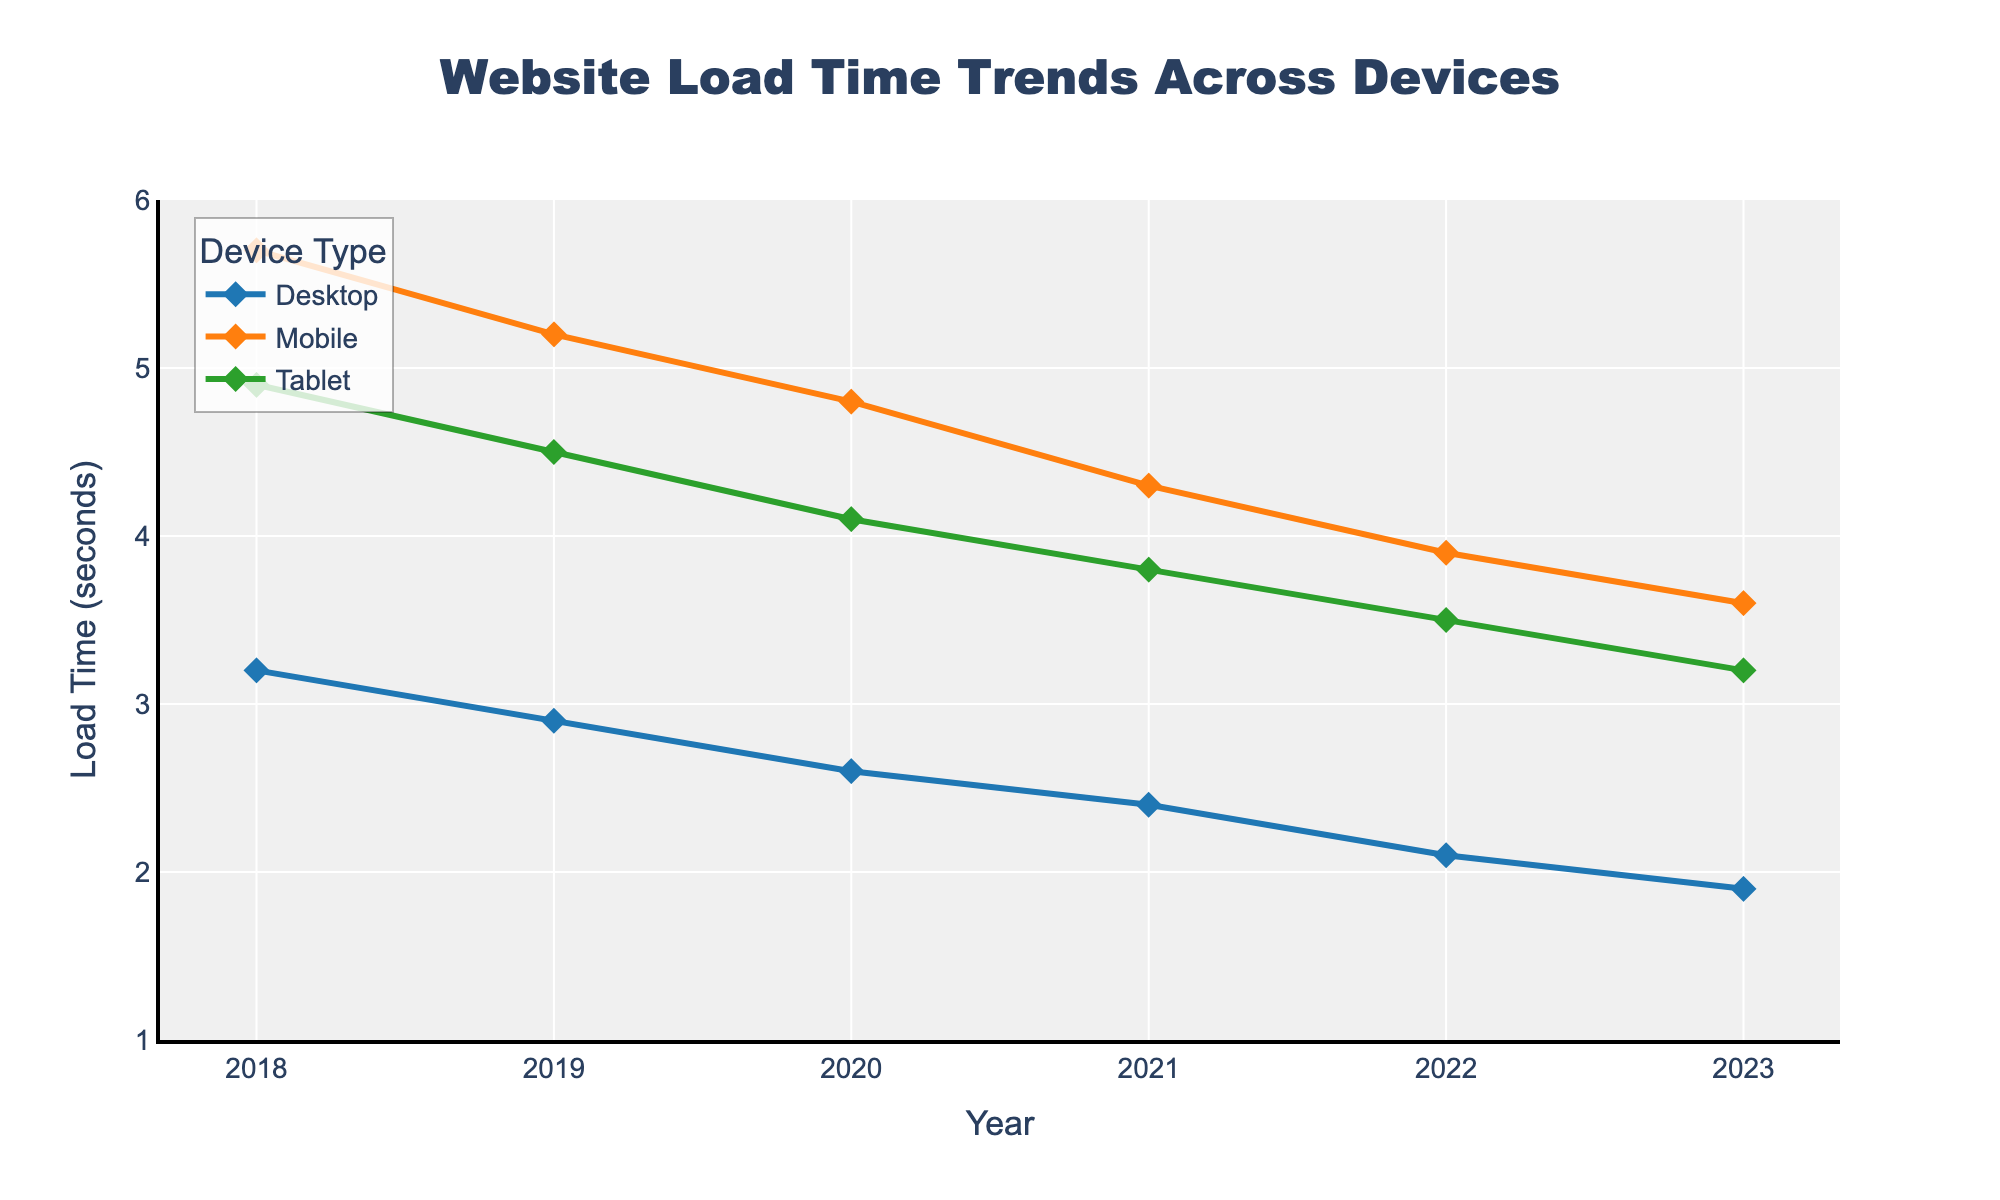What is the trend of website load times for Mobile devices from 2018 to 2023? Examine the line corresponding to Mobile devices. The load times have gradually decreased each year: from 5.7 seconds in 2018 to 3.6 seconds in 2023
Answer: Decreasing In which year did Desktop and Tablet devices have the same load time, if any? Track the lines for both Desktop and Tablet devices across all years. In each year, Desktop load times are consistently lower than Tablet load times, so they never match.
Answer: Never What is the difference in website load time between Mobile and Desktop devices in 2022? In 2022, the load time for Mobile is 3.9 seconds, and for Desktop, it is 2.1 seconds. Subtract the Desktop value from the Mobile value: 3.9 - 2.1
Answer: 1.8 seconds Which device showed the most significant improvement in load time from 2018 to 2023? Calculate the total reduction in load time for each device over the period. Desktop: 3.2 - 1.9 = 1.3 seconds, Mobile: 5.7 - 3.6 = 2.1 seconds, Tablet: 4.9 - 3.2 = 1.7 seconds. The Mobile device has the largest reduction (2.1 seconds).
Answer: Mobile What was the average load time for Tablet devices over the 6-year period? Sum the Tablet load times and divide by the number of years: (4.9 + 4.5 + 4.1 + 3.8 + 3.5 + 3.2) / 6. This equals 24 / 6
Answer: 4.0 seconds Compare the load times for Desktop and Mobile devices in the year 2023. Which one is faster, and by how much? For 2023, the load time for Desktop is 1.9 seconds and for Mobile, it is 3.6 seconds. The difference in load times is 3.6 - 1.9. Desktop is faster by that amount.
Answer: Desktop is faster by 1.7 seconds What color represents the Tablet device trend line in the figure? Visualize the line colors in the plot. The Tablet device is represented by the green line.
Answer: Green In which year did the Mobile device show the greatest decrease in load time compared to the previous year? Check the year-over-year decreases for Mobile: 2019 (5.7 - 5.2 = 0.5), 2020 (5.2 - 4.8 = 0.4), 2021 (4.8 - 4.3 = 0.5), 2022 (4.3 - 3.9 = 0.4), 2023 (3.9 - 3.6 = 0.3). The decreases in 2019 and 2021 are both 0.5 seconds, the maximum.
Answer: 2019 and 2021 